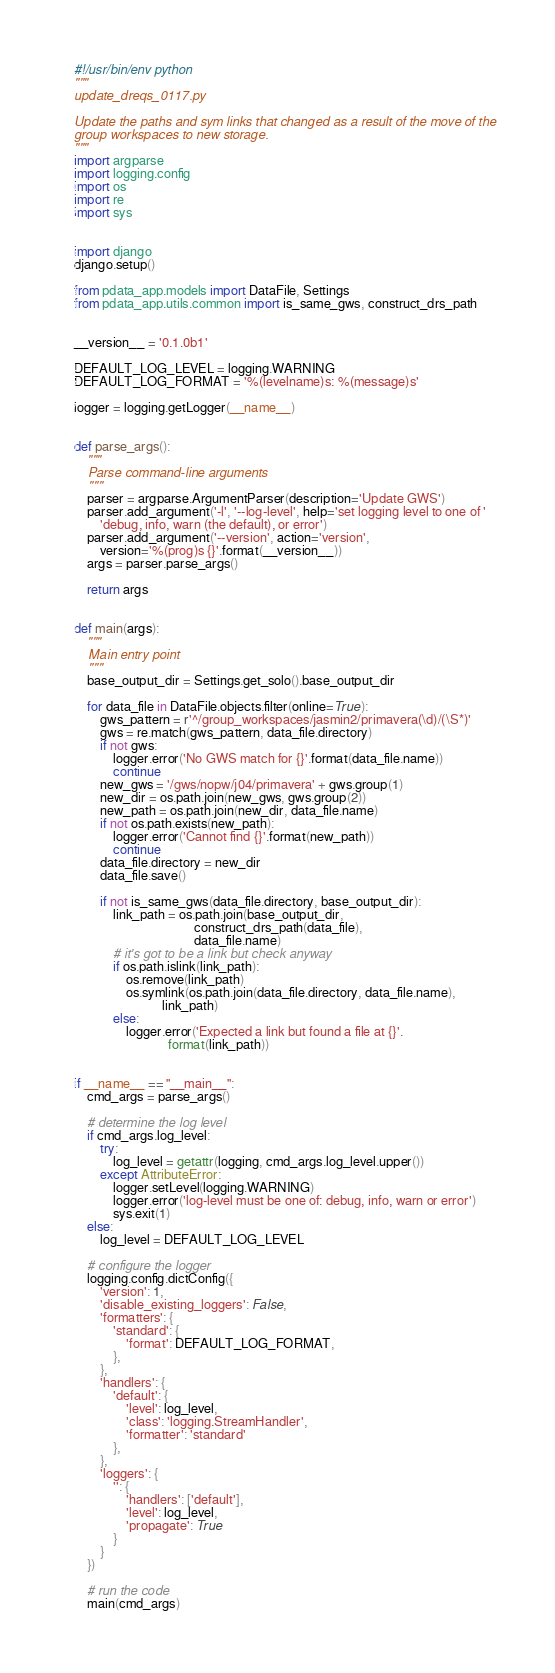<code> <loc_0><loc_0><loc_500><loc_500><_Python_>#!/usr/bin/env python
"""
update_dreqs_0117.py

Update the paths and sym links that changed as a result of the move of the
group workspaces to new storage.
"""
import argparse
import logging.config
import os
import re
import sys


import django
django.setup()

from pdata_app.models import DataFile, Settings
from pdata_app.utils.common import is_same_gws, construct_drs_path


__version__ = '0.1.0b1'

DEFAULT_LOG_LEVEL = logging.WARNING
DEFAULT_LOG_FORMAT = '%(levelname)s: %(message)s'

logger = logging.getLogger(__name__)


def parse_args():
    """
    Parse command-line arguments
    """
    parser = argparse.ArgumentParser(description='Update GWS')
    parser.add_argument('-l', '--log-level', help='set logging level to one of '
        'debug, info, warn (the default), or error')
    parser.add_argument('--version', action='version',
        version='%(prog)s {}'.format(__version__))
    args = parser.parse_args()

    return args


def main(args):
    """
    Main entry point
    """
    base_output_dir = Settings.get_solo().base_output_dir

    for data_file in DataFile.objects.filter(online=True):
        gws_pattern = r'^/group_workspaces/jasmin2/primavera(\d)/(\S*)'
        gws = re.match(gws_pattern, data_file.directory)
        if not gws:
            logger.error('No GWS match for {}'.format(data_file.name))
            continue
        new_gws = '/gws/nopw/j04/primavera' + gws.group(1)
        new_dir = os.path.join(new_gws, gws.group(2))
        new_path = os.path.join(new_dir, data_file.name)
        if not os.path.exists(new_path):
            logger.error('Cannot find {}'.format(new_path))
            continue
        data_file.directory = new_dir
        data_file.save()

        if not is_same_gws(data_file.directory, base_output_dir):
            link_path = os.path.join(base_output_dir,
                                     construct_drs_path(data_file),
                                     data_file.name)
            # it's got to be a link but check anyway
            if os.path.islink(link_path):
                os.remove(link_path)
                os.symlink(os.path.join(data_file.directory, data_file.name),
                           link_path)
            else:
                logger.error('Expected a link but found a file at {}'.
                             format(link_path))


if __name__ == "__main__":
    cmd_args = parse_args()

    # determine the log level
    if cmd_args.log_level:
        try:
            log_level = getattr(logging, cmd_args.log_level.upper())
        except AttributeError:
            logger.setLevel(logging.WARNING)
            logger.error('log-level must be one of: debug, info, warn or error')
            sys.exit(1)
    else:
        log_level = DEFAULT_LOG_LEVEL

    # configure the logger
    logging.config.dictConfig({
        'version': 1,
        'disable_existing_loggers': False,
        'formatters': {
            'standard': {
                'format': DEFAULT_LOG_FORMAT,
            },
        },
        'handlers': {
            'default': {
                'level': log_level,
                'class': 'logging.StreamHandler',
                'formatter': 'standard'
            },
        },
        'loggers': {
            '': {
                'handlers': ['default'],
                'level': log_level,
                'propagate': True
            }
        }
    })

    # run the code
    main(cmd_args)
</code> 